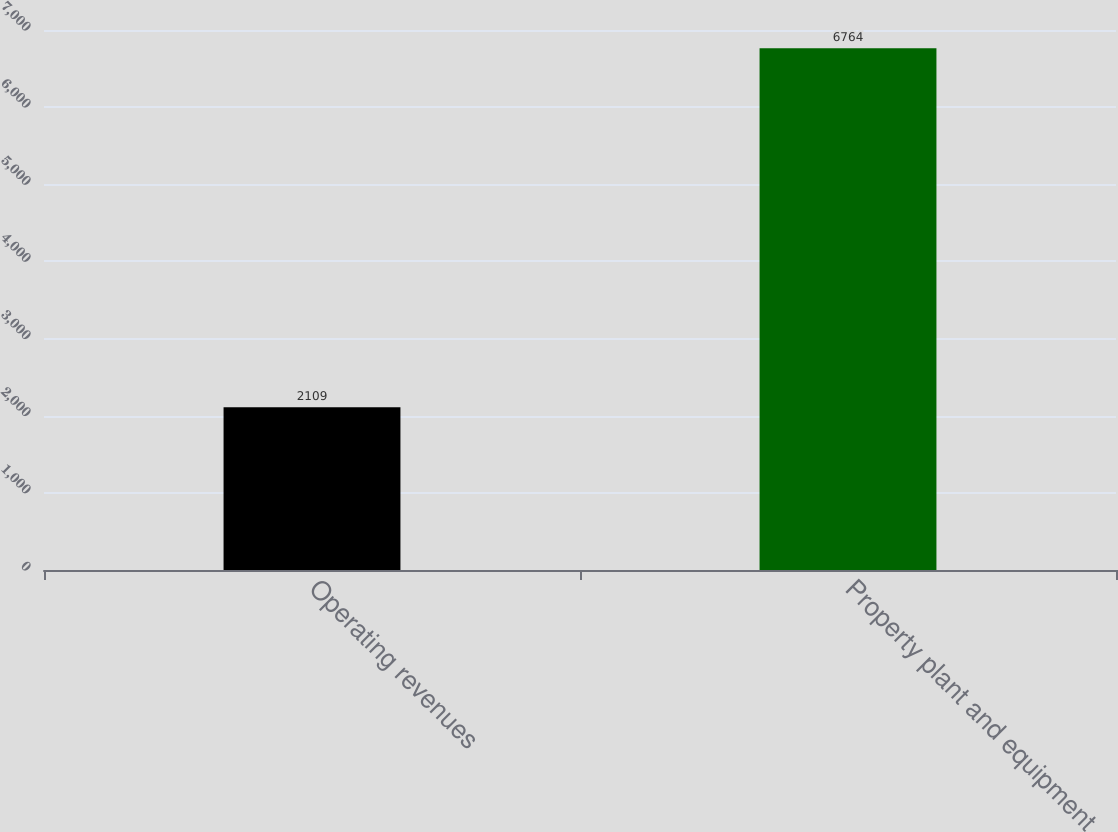<chart> <loc_0><loc_0><loc_500><loc_500><bar_chart><fcel>Operating revenues<fcel>Property plant and equipment<nl><fcel>2109<fcel>6764<nl></chart> 